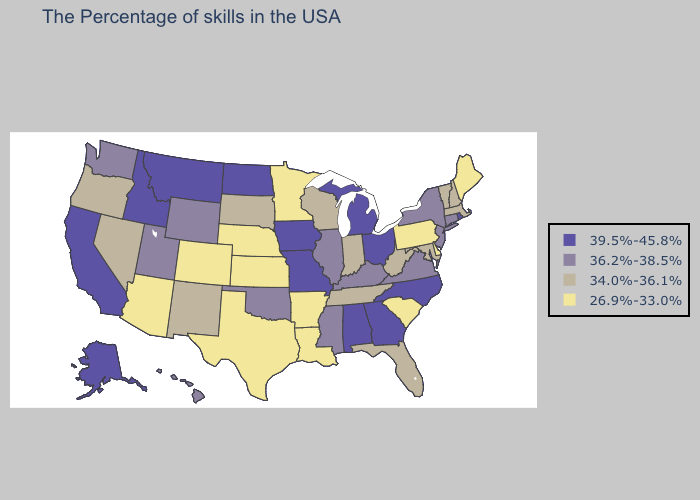What is the value of Kansas?
Give a very brief answer. 26.9%-33.0%. Which states have the highest value in the USA?
Keep it brief. Rhode Island, North Carolina, Ohio, Georgia, Michigan, Alabama, Missouri, Iowa, North Dakota, Montana, Idaho, California, Alaska. What is the highest value in the Northeast ?
Keep it brief. 39.5%-45.8%. Does South Dakota have the lowest value in the USA?
Quick response, please. No. Does Maryland have a higher value than Utah?
Give a very brief answer. No. What is the value of Nevada?
Keep it brief. 34.0%-36.1%. Which states have the lowest value in the USA?
Short answer required. Maine, Delaware, Pennsylvania, South Carolina, Louisiana, Arkansas, Minnesota, Kansas, Nebraska, Texas, Colorado, Arizona. What is the value of Maryland?
Give a very brief answer. 34.0%-36.1%. What is the highest value in states that border Wyoming?
Be succinct. 39.5%-45.8%. Does North Dakota have a higher value than Alaska?
Quick response, please. No. Among the states that border Tennessee , which have the lowest value?
Write a very short answer. Arkansas. Name the states that have a value in the range 26.9%-33.0%?
Answer briefly. Maine, Delaware, Pennsylvania, South Carolina, Louisiana, Arkansas, Minnesota, Kansas, Nebraska, Texas, Colorado, Arizona. Does the map have missing data?
Short answer required. No. Among the states that border Missouri , does Oklahoma have the lowest value?
Give a very brief answer. No. 